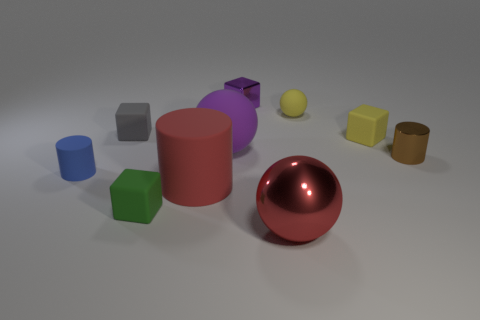Subtract all cubes. How many objects are left? 6 Subtract 0 brown balls. How many objects are left? 10 Subtract all big objects. Subtract all brown things. How many objects are left? 6 Add 3 small yellow things. How many small yellow things are left? 5 Add 7 big brown metal cubes. How many big brown metal cubes exist? 7 